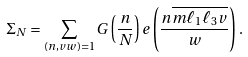Convert formula to latex. <formula><loc_0><loc_0><loc_500><loc_500>\Sigma _ { N } & = \sum _ { ( n , v w ) = 1 } G \left ( \frac { n } { N } \right ) e \left ( \frac { n \overline { m \ell _ { 1 } \ell _ { 3 } v } } { w } \right ) .</formula> 